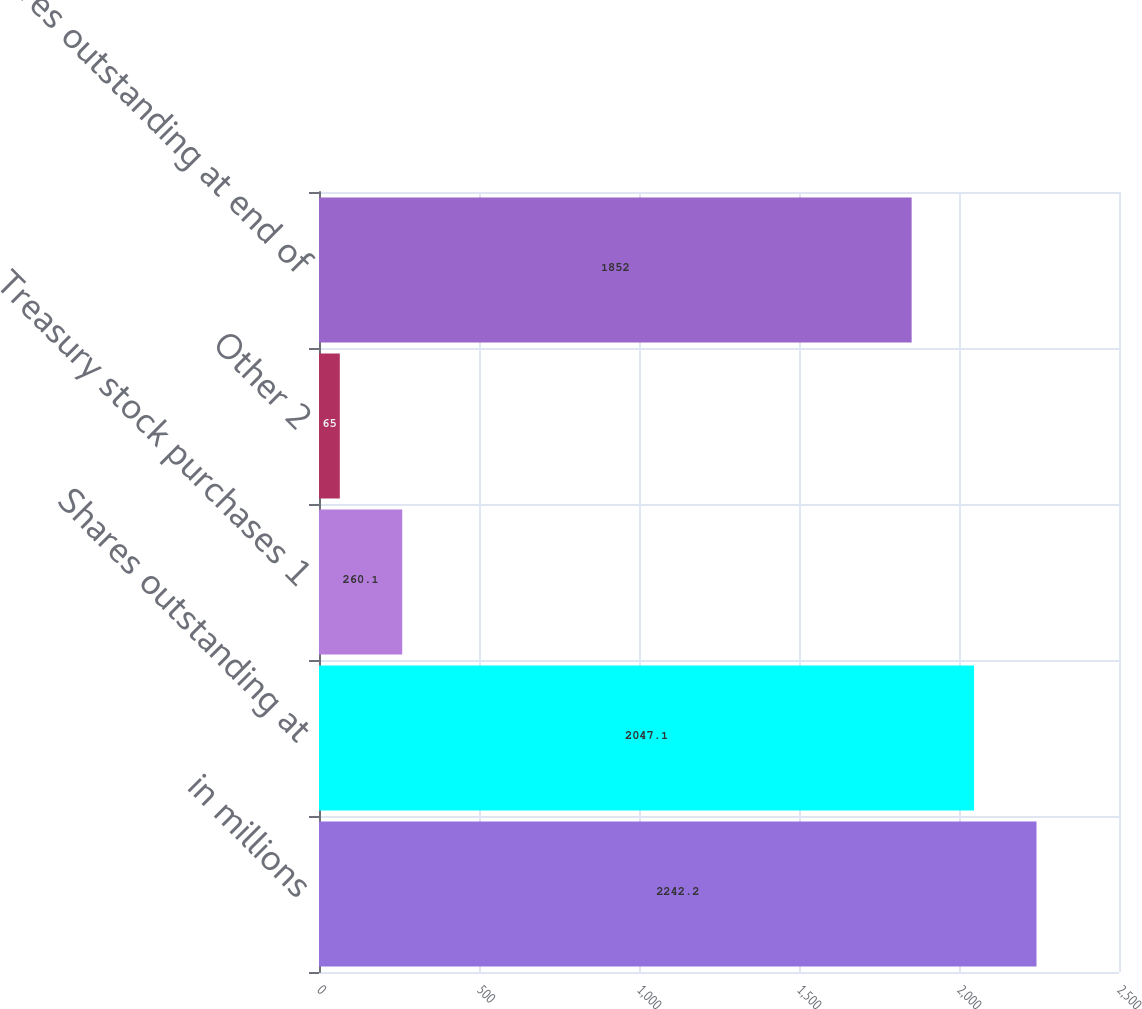Convert chart to OTSL. <chart><loc_0><loc_0><loc_500><loc_500><bar_chart><fcel>in millions<fcel>Shares outstanding at<fcel>Treasury stock purchases 1<fcel>Other 2<fcel>Shares outstanding at end of<nl><fcel>2242.2<fcel>2047.1<fcel>260.1<fcel>65<fcel>1852<nl></chart> 